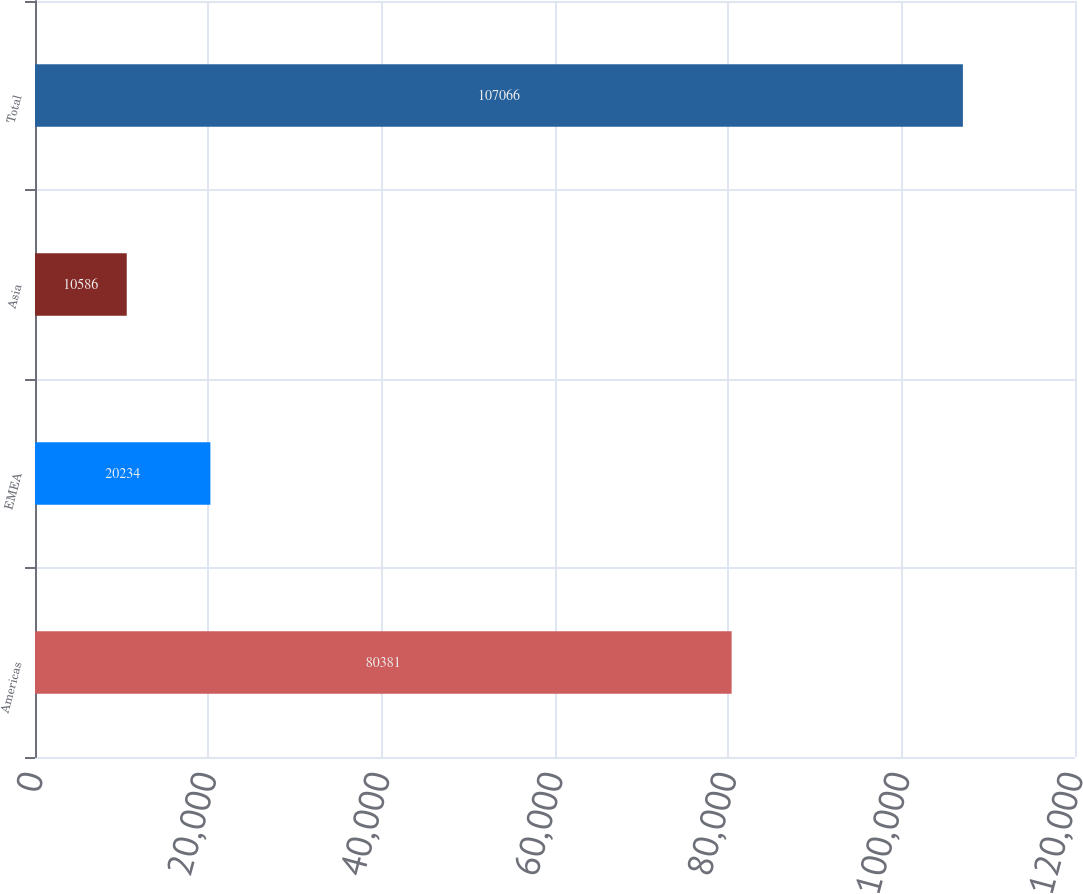Convert chart to OTSL. <chart><loc_0><loc_0><loc_500><loc_500><bar_chart><fcel>Americas<fcel>EMEA<fcel>Asia<fcel>Total<nl><fcel>80381<fcel>20234<fcel>10586<fcel>107066<nl></chart> 